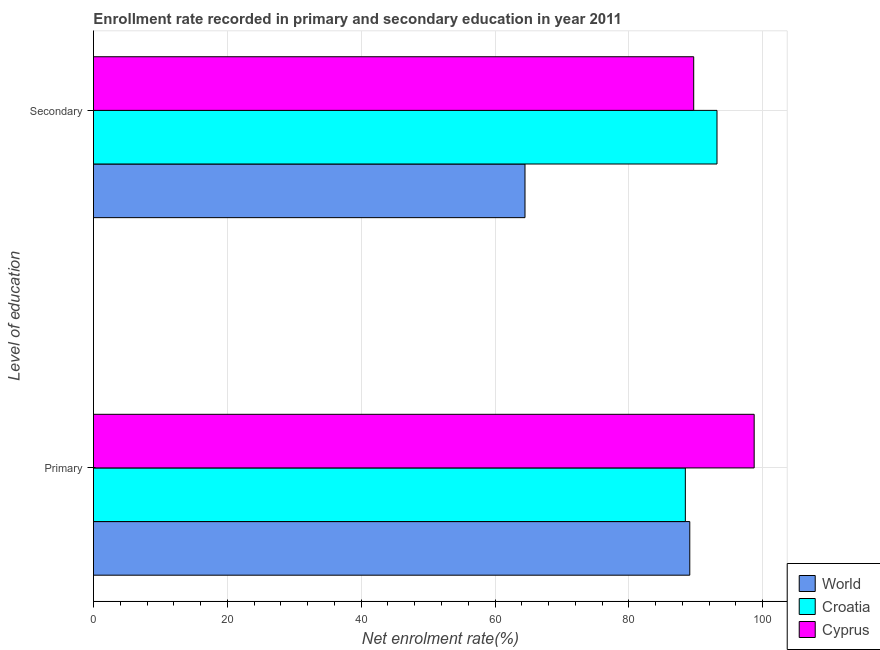How many groups of bars are there?
Give a very brief answer. 2. Are the number of bars on each tick of the Y-axis equal?
Your answer should be very brief. Yes. What is the label of the 1st group of bars from the top?
Your answer should be compact. Secondary. What is the enrollment rate in secondary education in Croatia?
Your response must be concise. 93.16. Across all countries, what is the maximum enrollment rate in primary education?
Your response must be concise. 98.72. Across all countries, what is the minimum enrollment rate in secondary education?
Offer a terse response. 64.48. In which country was the enrollment rate in secondary education maximum?
Offer a very short reply. Croatia. In which country was the enrollment rate in primary education minimum?
Your answer should be very brief. Croatia. What is the total enrollment rate in primary education in the graph?
Your answer should be compact. 276.25. What is the difference between the enrollment rate in primary education in World and that in Cyprus?
Keep it short and to the point. -9.62. What is the difference between the enrollment rate in primary education in World and the enrollment rate in secondary education in Cyprus?
Offer a very short reply. -0.59. What is the average enrollment rate in secondary education per country?
Your answer should be very brief. 82.44. What is the difference between the enrollment rate in secondary education and enrollment rate in primary education in World?
Your answer should be compact. -24.62. What is the ratio of the enrollment rate in primary education in Cyprus to that in Croatia?
Give a very brief answer. 1.12. Is the enrollment rate in secondary education in World less than that in Croatia?
Keep it short and to the point. Yes. In how many countries, is the enrollment rate in primary education greater than the average enrollment rate in primary education taken over all countries?
Provide a short and direct response. 1. What does the 2nd bar from the top in Primary represents?
Give a very brief answer. Croatia. What does the 3rd bar from the bottom in Primary represents?
Your response must be concise. Cyprus. How many countries are there in the graph?
Your response must be concise. 3. What is the difference between two consecutive major ticks on the X-axis?
Give a very brief answer. 20. Are the values on the major ticks of X-axis written in scientific E-notation?
Provide a short and direct response. No. Does the graph contain any zero values?
Make the answer very short. No. Does the graph contain grids?
Provide a short and direct response. Yes. Where does the legend appear in the graph?
Keep it short and to the point. Bottom right. How many legend labels are there?
Provide a succinct answer. 3. How are the legend labels stacked?
Ensure brevity in your answer.  Vertical. What is the title of the graph?
Ensure brevity in your answer.  Enrollment rate recorded in primary and secondary education in year 2011. What is the label or title of the X-axis?
Give a very brief answer. Net enrolment rate(%). What is the label or title of the Y-axis?
Your response must be concise. Level of education. What is the Net enrolment rate(%) of World in Primary?
Ensure brevity in your answer.  89.1. What is the Net enrolment rate(%) in Croatia in Primary?
Your answer should be very brief. 88.43. What is the Net enrolment rate(%) in Cyprus in Primary?
Keep it short and to the point. 98.72. What is the Net enrolment rate(%) in World in Secondary?
Make the answer very short. 64.48. What is the Net enrolment rate(%) of Croatia in Secondary?
Provide a short and direct response. 93.16. What is the Net enrolment rate(%) in Cyprus in Secondary?
Make the answer very short. 89.68. Across all Level of education, what is the maximum Net enrolment rate(%) in World?
Your response must be concise. 89.1. Across all Level of education, what is the maximum Net enrolment rate(%) of Croatia?
Offer a very short reply. 93.16. Across all Level of education, what is the maximum Net enrolment rate(%) of Cyprus?
Your response must be concise. 98.72. Across all Level of education, what is the minimum Net enrolment rate(%) of World?
Provide a succinct answer. 64.48. Across all Level of education, what is the minimum Net enrolment rate(%) in Croatia?
Make the answer very short. 88.43. Across all Level of education, what is the minimum Net enrolment rate(%) in Cyprus?
Make the answer very short. 89.68. What is the total Net enrolment rate(%) of World in the graph?
Provide a succinct answer. 153.58. What is the total Net enrolment rate(%) of Croatia in the graph?
Keep it short and to the point. 181.6. What is the total Net enrolment rate(%) in Cyprus in the graph?
Your answer should be very brief. 188.4. What is the difference between the Net enrolment rate(%) of World in Primary and that in Secondary?
Offer a very short reply. 24.62. What is the difference between the Net enrolment rate(%) of Croatia in Primary and that in Secondary?
Your response must be concise. -4.73. What is the difference between the Net enrolment rate(%) in Cyprus in Primary and that in Secondary?
Offer a terse response. 9.04. What is the difference between the Net enrolment rate(%) of World in Primary and the Net enrolment rate(%) of Croatia in Secondary?
Provide a succinct answer. -4.07. What is the difference between the Net enrolment rate(%) in World in Primary and the Net enrolment rate(%) in Cyprus in Secondary?
Your response must be concise. -0.59. What is the difference between the Net enrolment rate(%) in Croatia in Primary and the Net enrolment rate(%) in Cyprus in Secondary?
Keep it short and to the point. -1.25. What is the average Net enrolment rate(%) of World per Level of education?
Keep it short and to the point. 76.79. What is the average Net enrolment rate(%) of Croatia per Level of education?
Your response must be concise. 90.8. What is the average Net enrolment rate(%) of Cyprus per Level of education?
Offer a terse response. 94.2. What is the difference between the Net enrolment rate(%) in World and Net enrolment rate(%) in Croatia in Primary?
Provide a short and direct response. 0.66. What is the difference between the Net enrolment rate(%) of World and Net enrolment rate(%) of Cyprus in Primary?
Offer a very short reply. -9.62. What is the difference between the Net enrolment rate(%) of Croatia and Net enrolment rate(%) of Cyprus in Primary?
Your answer should be compact. -10.28. What is the difference between the Net enrolment rate(%) of World and Net enrolment rate(%) of Croatia in Secondary?
Offer a terse response. -28.69. What is the difference between the Net enrolment rate(%) of World and Net enrolment rate(%) of Cyprus in Secondary?
Provide a short and direct response. -25.21. What is the difference between the Net enrolment rate(%) in Croatia and Net enrolment rate(%) in Cyprus in Secondary?
Give a very brief answer. 3.48. What is the ratio of the Net enrolment rate(%) of World in Primary to that in Secondary?
Your response must be concise. 1.38. What is the ratio of the Net enrolment rate(%) of Croatia in Primary to that in Secondary?
Offer a very short reply. 0.95. What is the ratio of the Net enrolment rate(%) of Cyprus in Primary to that in Secondary?
Ensure brevity in your answer.  1.1. What is the difference between the highest and the second highest Net enrolment rate(%) in World?
Your answer should be very brief. 24.62. What is the difference between the highest and the second highest Net enrolment rate(%) of Croatia?
Give a very brief answer. 4.73. What is the difference between the highest and the second highest Net enrolment rate(%) in Cyprus?
Ensure brevity in your answer.  9.04. What is the difference between the highest and the lowest Net enrolment rate(%) in World?
Keep it short and to the point. 24.62. What is the difference between the highest and the lowest Net enrolment rate(%) in Croatia?
Offer a terse response. 4.73. What is the difference between the highest and the lowest Net enrolment rate(%) of Cyprus?
Ensure brevity in your answer.  9.04. 